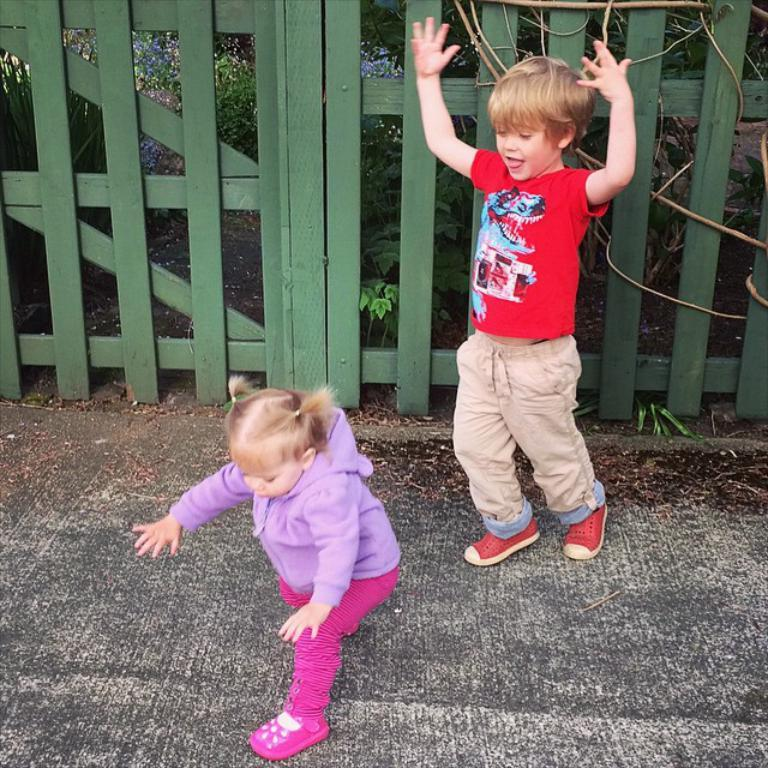How many people are in the image? There is a boy and a girl in the image. What are the boy and girl doing in the image? The boy and girl appear to be playing. What is at the bottom of the image? There is a walkway at the bottom of the image. What can be seen in the background of the image? There is a fence, plants, and flowers visible in the background of the image. What type of record can be seen in the image? There is no record present in the image. What is the boy feeding to the goldfish in the image? There are no goldfish present in the image. 